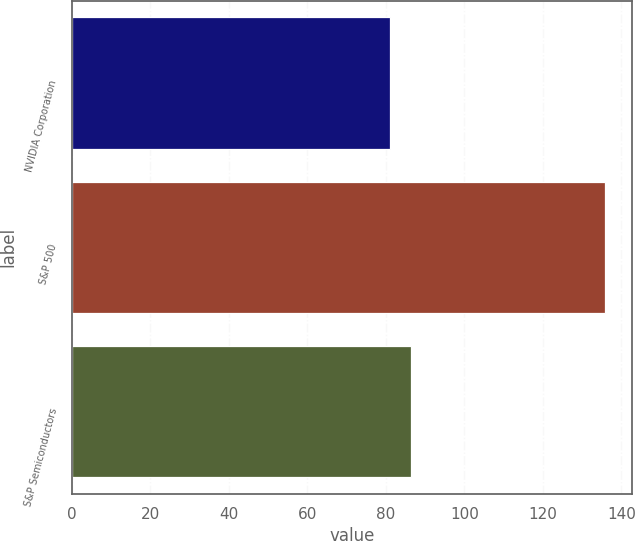Convert chart to OTSL. <chart><loc_0><loc_0><loc_500><loc_500><bar_chart><fcel>NVIDIA Corporation<fcel>S&P 500<fcel>S&P Semiconductors<nl><fcel>80.98<fcel>135.92<fcel>86.47<nl></chart> 